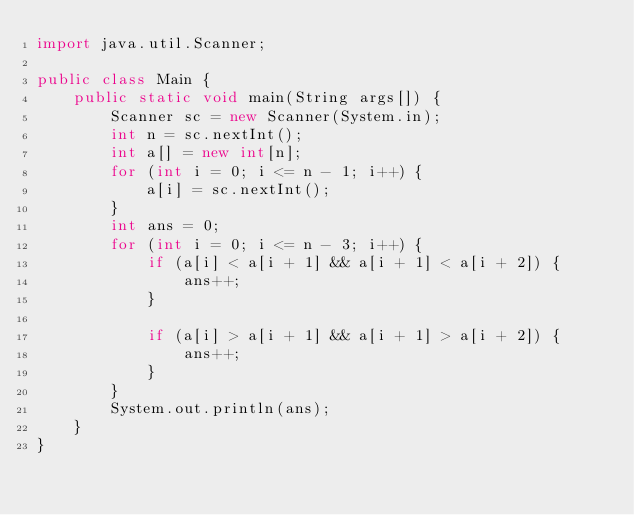Convert code to text. <code><loc_0><loc_0><loc_500><loc_500><_Java_>import java.util.Scanner;

public class Main {
	public static void main(String args[]) {
		Scanner sc = new Scanner(System.in);
		int n = sc.nextInt();
		int a[] = new int[n];
		for (int i = 0; i <= n - 1; i++) {
			a[i] = sc.nextInt();
		}
		int ans = 0;
		for (int i = 0; i <= n - 3; i++) {
			if (a[i] < a[i + 1] && a[i + 1] < a[i + 2]) {
				ans++;
			}

			if (a[i] > a[i + 1] && a[i + 1] > a[i + 2]) {
				ans++;
			}
		}
		System.out.println(ans);
	}
}</code> 